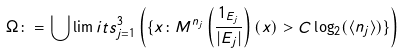<formula> <loc_0><loc_0><loc_500><loc_500>\Omega \colon = \bigcup \lim i t s _ { j = 1 } ^ { 3 } \left ( \{ x \colon M ^ { n _ { j } } \left ( \frac { 1 _ { E _ { j } } } { | E _ { j } | } \right ) ( x ) > C \log _ { 2 } ( \langle n _ { j } \rangle ) \} \right )</formula> 